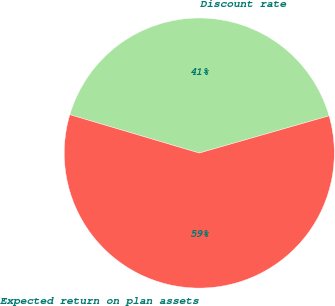Convert chart. <chart><loc_0><loc_0><loc_500><loc_500><pie_chart><fcel>Discount rate<fcel>Expected return on plan assets<nl><fcel>40.97%<fcel>59.03%<nl></chart> 